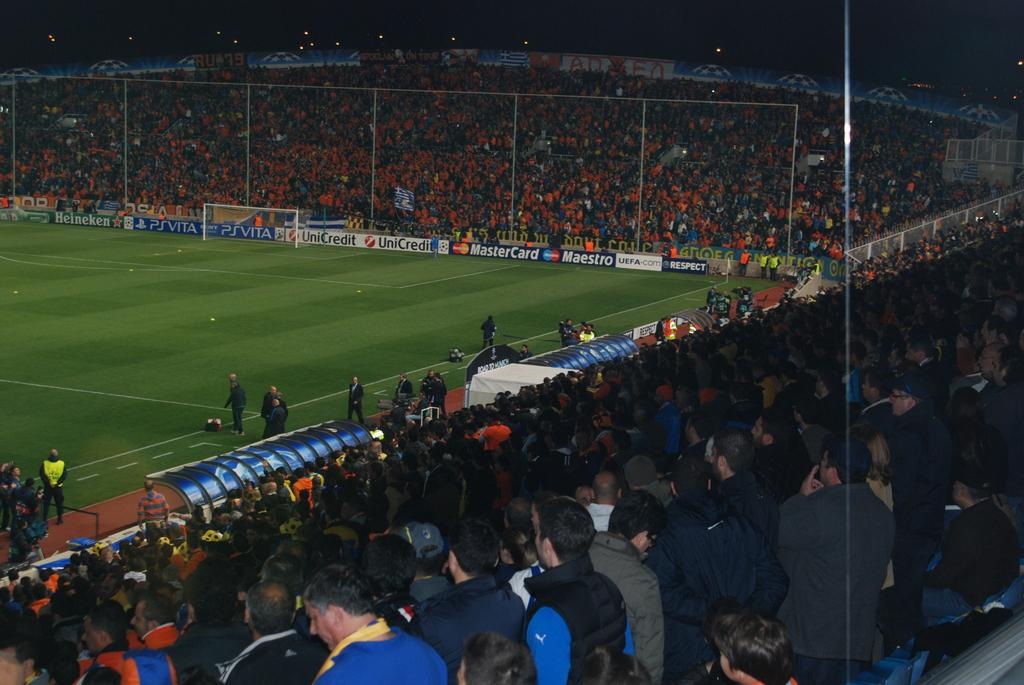What are the people in the image doing? The groups of people are standing and sitting in the image. Where is the image likely taken? The location appears to be a football ground, as indicated by the presence of a football goal post. What type of advertisements or promotions might be visible in the image? There are hoardings visible in the image, which could be displaying advertisements or promotions. What feature can be seen surrounding the football ground? There is a fence in the image, which likely surrounds the football ground. Where is the faucet located in the image? There is no faucet present in the image. What type of cart is being used by the people in the image? There is no cart visible in the image. 